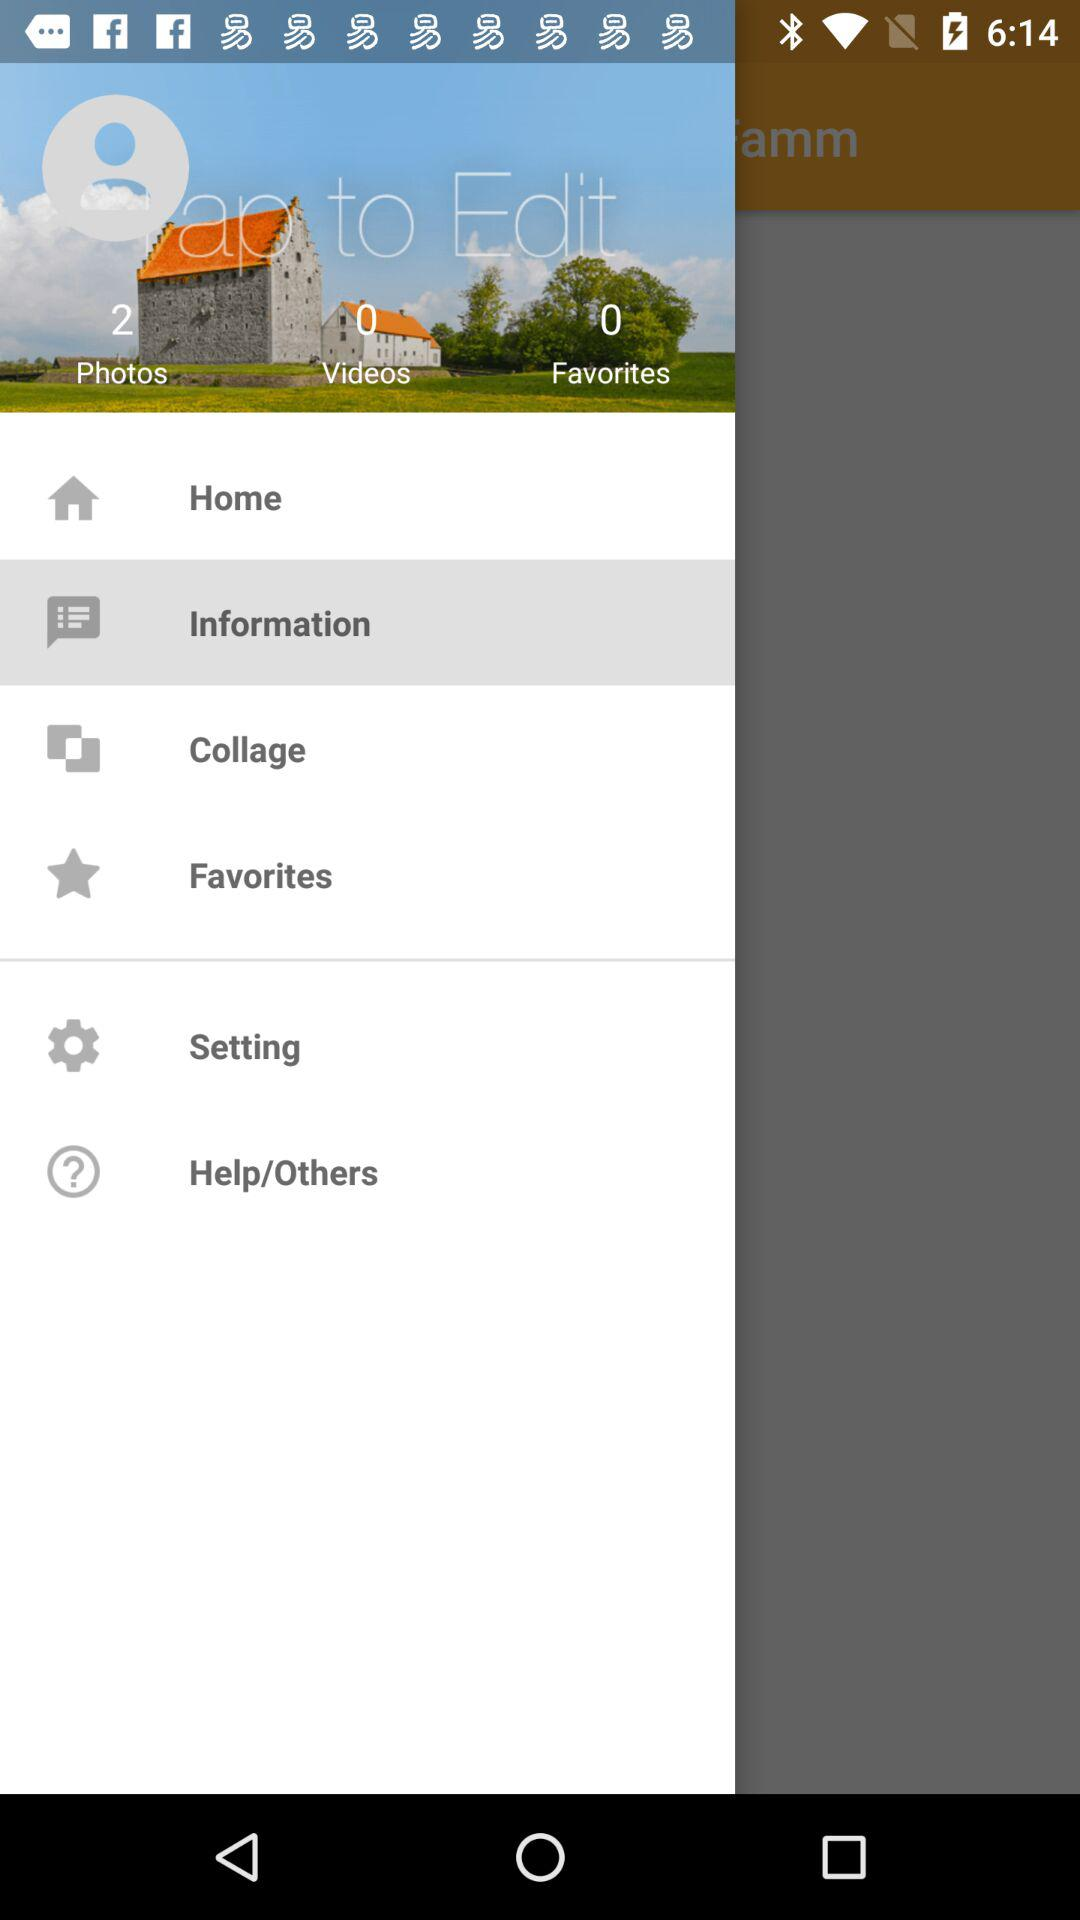How many favorites are there? There are 0 favorites. 